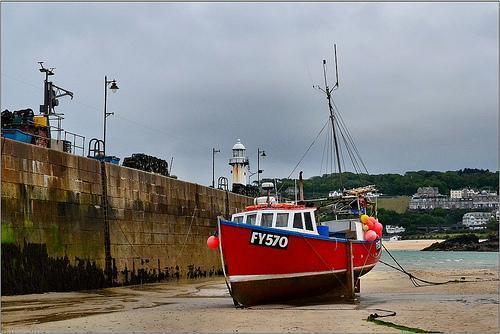How many red boats are shown?
Give a very brief answer. 1. 